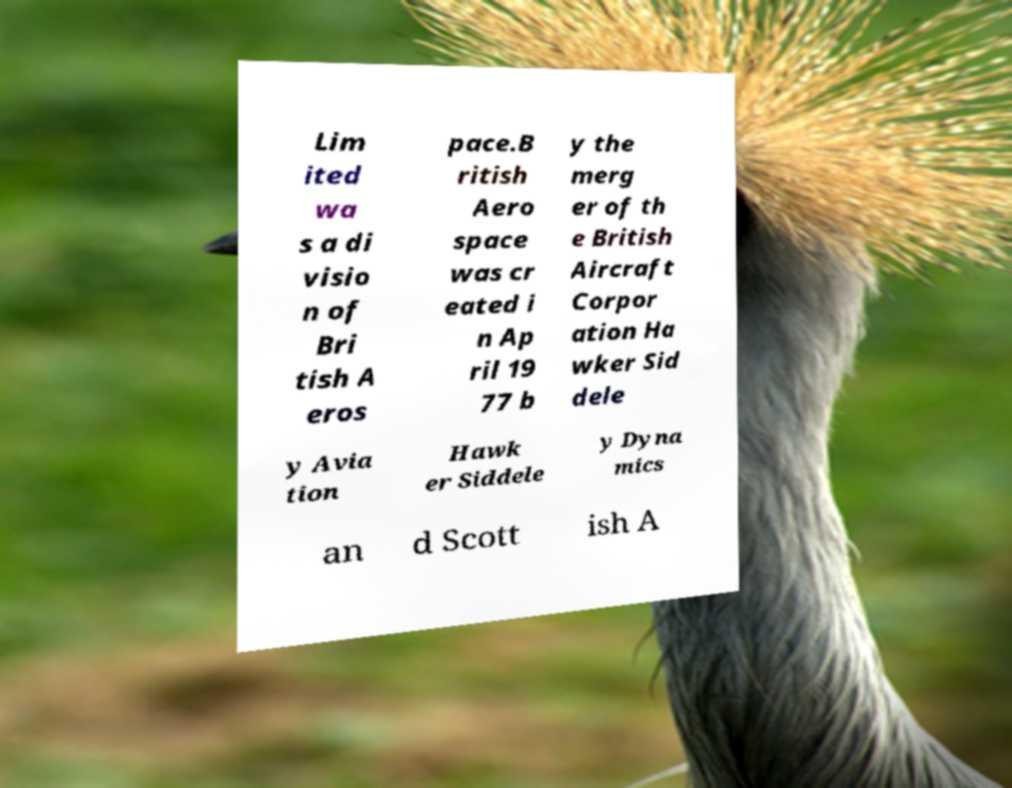Can you accurately transcribe the text from the provided image for me? Lim ited wa s a di visio n of Bri tish A eros pace.B ritish Aero space was cr eated i n Ap ril 19 77 b y the merg er of th e British Aircraft Corpor ation Ha wker Sid dele y Avia tion Hawk er Siddele y Dyna mics an d Scott ish A 